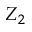Convert formula to latex. <formula><loc_0><loc_0><loc_500><loc_500>Z _ { 2 }</formula> 